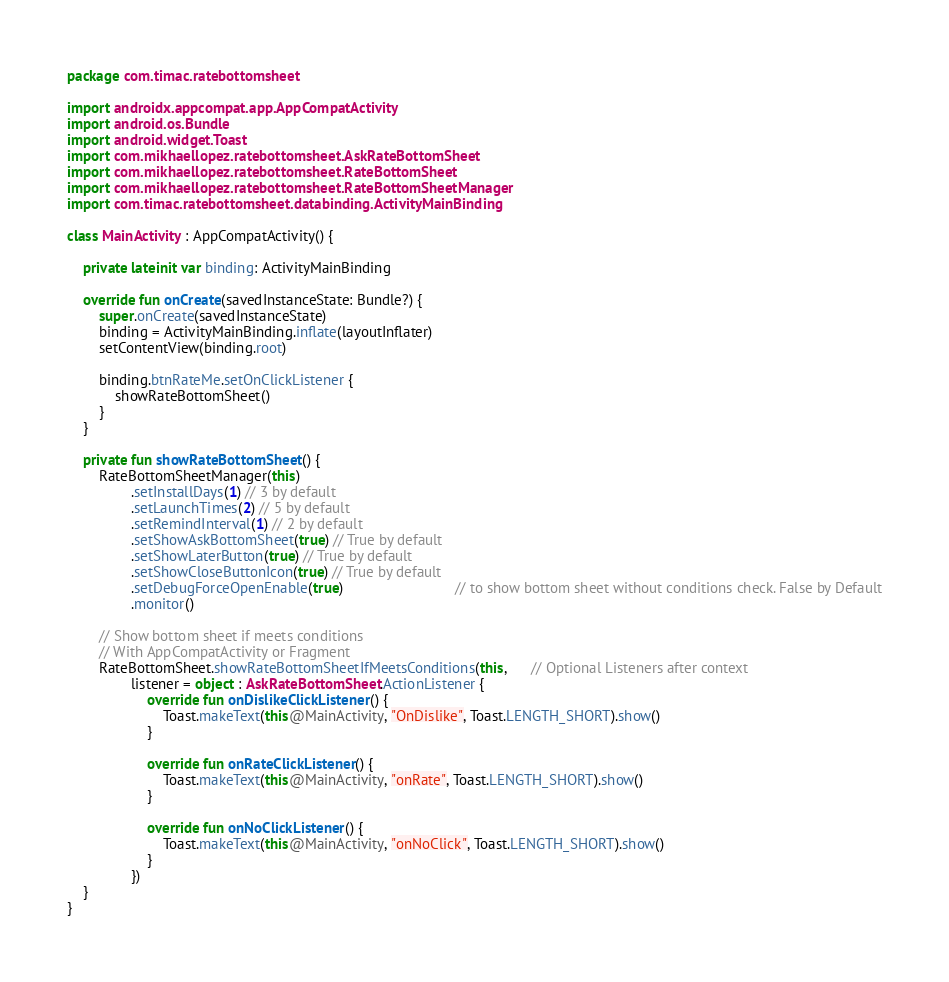Convert code to text. <code><loc_0><loc_0><loc_500><loc_500><_Kotlin_>package com.timac.ratebottomsheet

import androidx.appcompat.app.AppCompatActivity
import android.os.Bundle
import android.widget.Toast
import com.mikhaellopez.ratebottomsheet.AskRateBottomSheet
import com.mikhaellopez.ratebottomsheet.RateBottomSheet
import com.mikhaellopez.ratebottomsheet.RateBottomSheetManager
import com.timac.ratebottomsheet.databinding.ActivityMainBinding

class MainActivity : AppCompatActivity() {

    private lateinit var binding: ActivityMainBinding

    override fun onCreate(savedInstanceState: Bundle?) {
        super.onCreate(savedInstanceState)
        binding = ActivityMainBinding.inflate(layoutInflater)
        setContentView(binding.root)

        binding.btnRateMe.setOnClickListener {
            showRateBottomSheet()
        }
    }

    private fun showRateBottomSheet() {
        RateBottomSheetManager(this)
                .setInstallDays(1) // 3 by default
                .setLaunchTimes(2) // 5 by default
                .setRemindInterval(1) // 2 by default
                .setShowAskBottomSheet(true) // True by default
                .setShowLaterButton(true) // True by default
                .setShowCloseButtonIcon(true) // True by default
                .setDebugForceOpenEnable(true)                            // to show bottom sheet without conditions check. False by Default
                .monitor()

        // Show bottom sheet if meets conditions
        // With AppCompatActivity or Fragment
        RateBottomSheet.showRateBottomSheetIfMeetsConditions(this,      // Optional Listeners after context
                listener = object : AskRateBottomSheet.ActionListener {
                    override fun onDislikeClickListener() {
                        Toast.makeText(this@MainActivity, "OnDislike", Toast.LENGTH_SHORT).show()
                    }

                    override fun onRateClickListener() {
                        Toast.makeText(this@MainActivity, "onRate", Toast.LENGTH_SHORT).show()
                    }

                    override fun onNoClickListener() {
                        Toast.makeText(this@MainActivity, "onNoClick", Toast.LENGTH_SHORT).show()
                    }
                })
    }
}</code> 